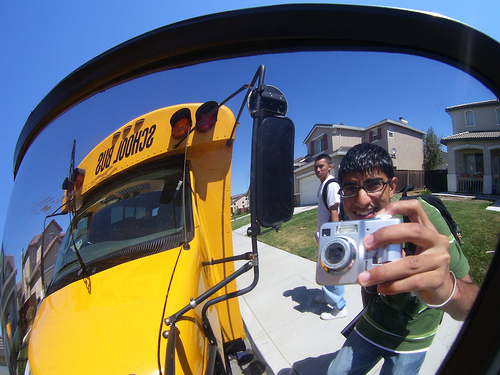Please provide a short description for this region: [0.66, 0.41, 0.96, 0.87]. This region depicts a man wearing blue jeans, and he appears to be holding a camera. 